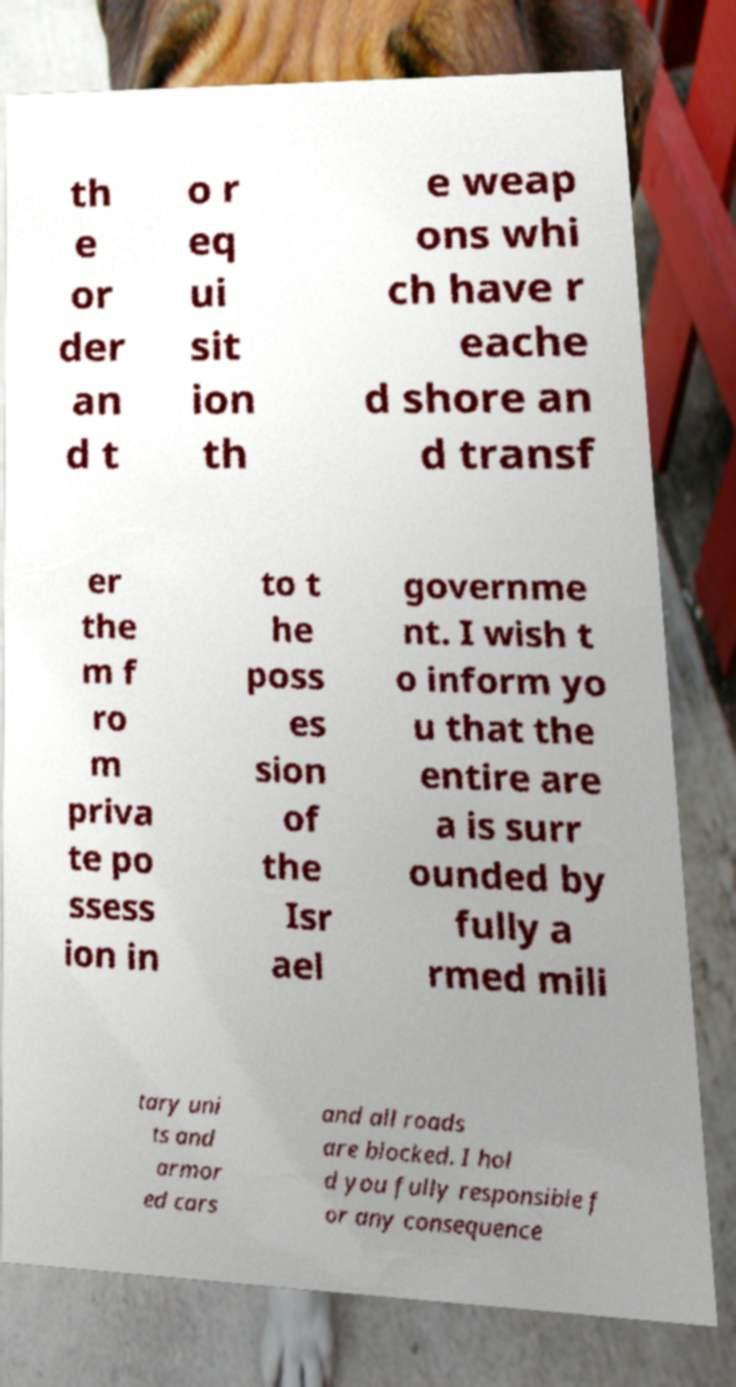What messages or text are displayed in this image? I need them in a readable, typed format. th e or der an d t o r eq ui sit ion th e weap ons whi ch have r eache d shore an d transf er the m f ro m priva te po ssess ion in to t he poss es sion of the Isr ael governme nt. I wish t o inform yo u that the entire are a is surr ounded by fully a rmed mili tary uni ts and armor ed cars and all roads are blocked. I hol d you fully responsible f or any consequence 